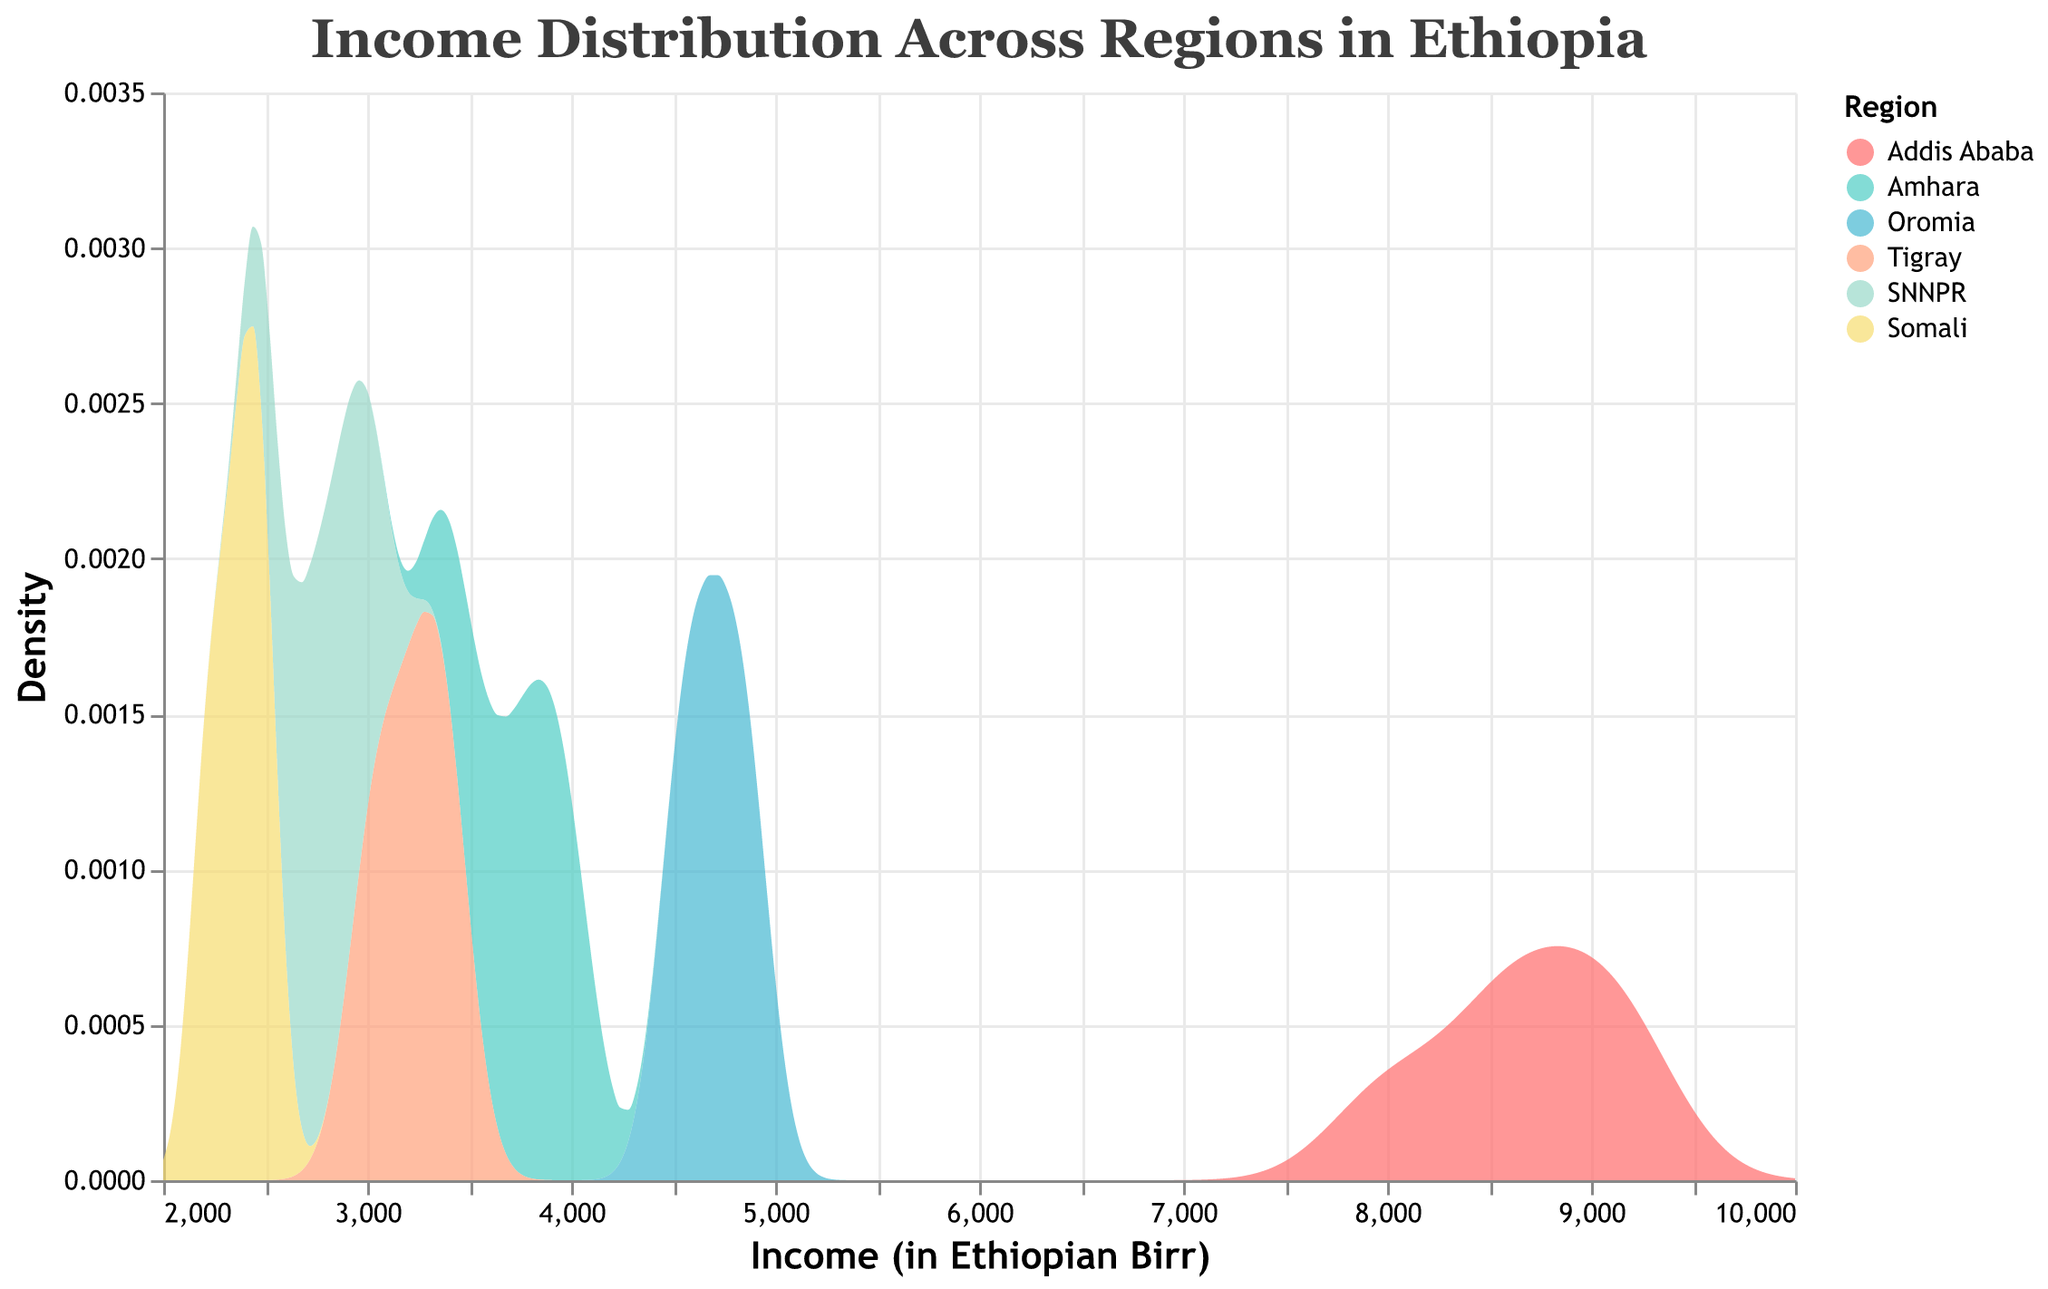What's the title of the figure? Look at the top of the figure; the title is prominently displayed. The title is a short and clear description of what the figure represents.
Answer: Income Distribution Across Regions in Ethiopia What does the x-axis represent? The x-axis label is slightly above the axis line. It tells us what the values along the x-axis indicate.
Answer: Income (in Ethiopian Birr) Which region appears to have the highest income density peak? Look across the different density curves. The region with the highest peak will have the tallest curve.
Answer: Addis Ababa What's the range of income displayed in the x-axis? Check the minimum and maximum values along the x-axis to determine the income range shown in the plot.
Answer: 2000 to 10000 Which two regions have the closest income density peaks? Compare the height and position of the peaks for all regions. The regions with peaks that are nearest to each other height-wise are the closest.
Answer: Oromia and Amhara How many distinct regions are represented by different density curves in the plot? Identify the number of distinct colors and labels in the legend. Each color/label combination represents a different region.
Answer: 6 Which region shows the lowest range of income density values? Examine the width of the density curves for each region. The curve with the narrowest spread indicates the smallest income range.
Answer: Somali What is the main color used to represent the Amhara region? Refer to the legend matching colors with regions. Look for the color next to the 'Amhara' label.
Answer: Teal Between Oromia and Tigray, which region has a higher income density at an income of 4000 Birr? Locate the income value of 4000 on the x-axis and compare the corresponding heights (densities) of the curves for Oromia and Tigray at that point.
Answer: Tigray What does the y-axis represent? Look slightly above the y-axis for the label of the axis. This label describes what the y-axis values mean.
Answer: Density 